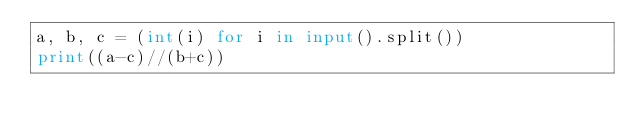<code> <loc_0><loc_0><loc_500><loc_500><_Python_>a, b, c = (int(i) for i in input().split())  
print((a-c)//(b+c))</code> 